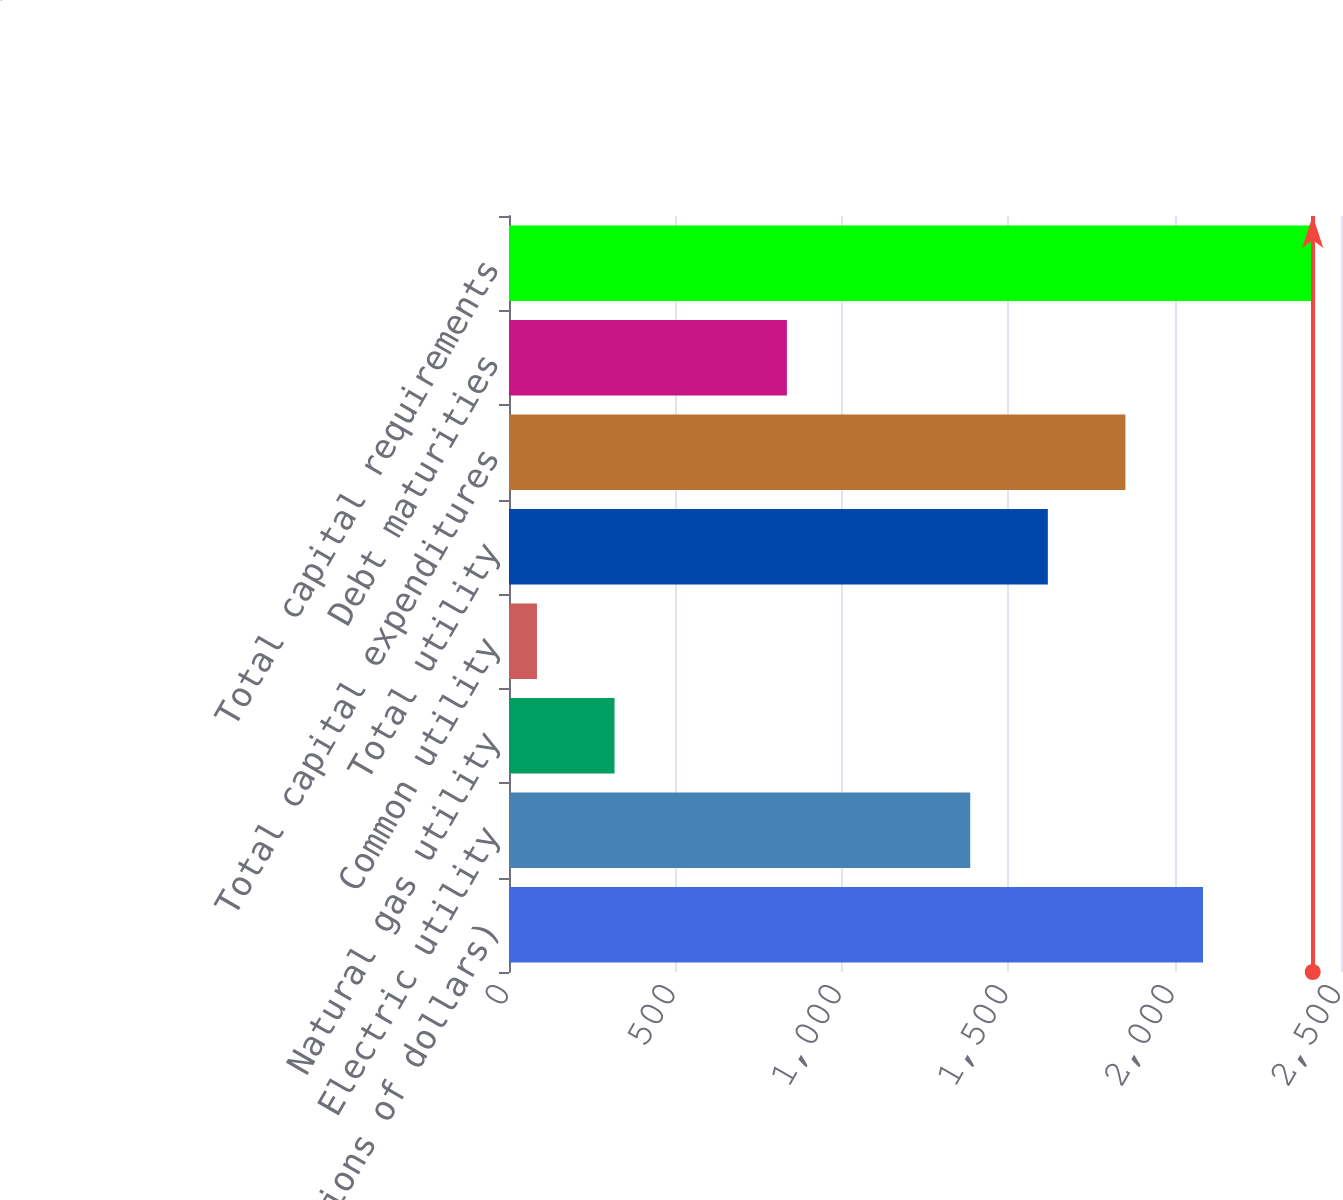<chart> <loc_0><loc_0><loc_500><loc_500><bar_chart><fcel>(Millions of dollars)<fcel>Electric utility<fcel>Natural gas utility<fcel>Common utility<fcel>Total utility<fcel>Total capital expenditures<fcel>Debt maturities<fcel>Total capital requirements<nl><fcel>2085.3<fcel>1386<fcel>317.1<fcel>84<fcel>1619.1<fcel>1852.2<fcel>835<fcel>2415<nl></chart> 